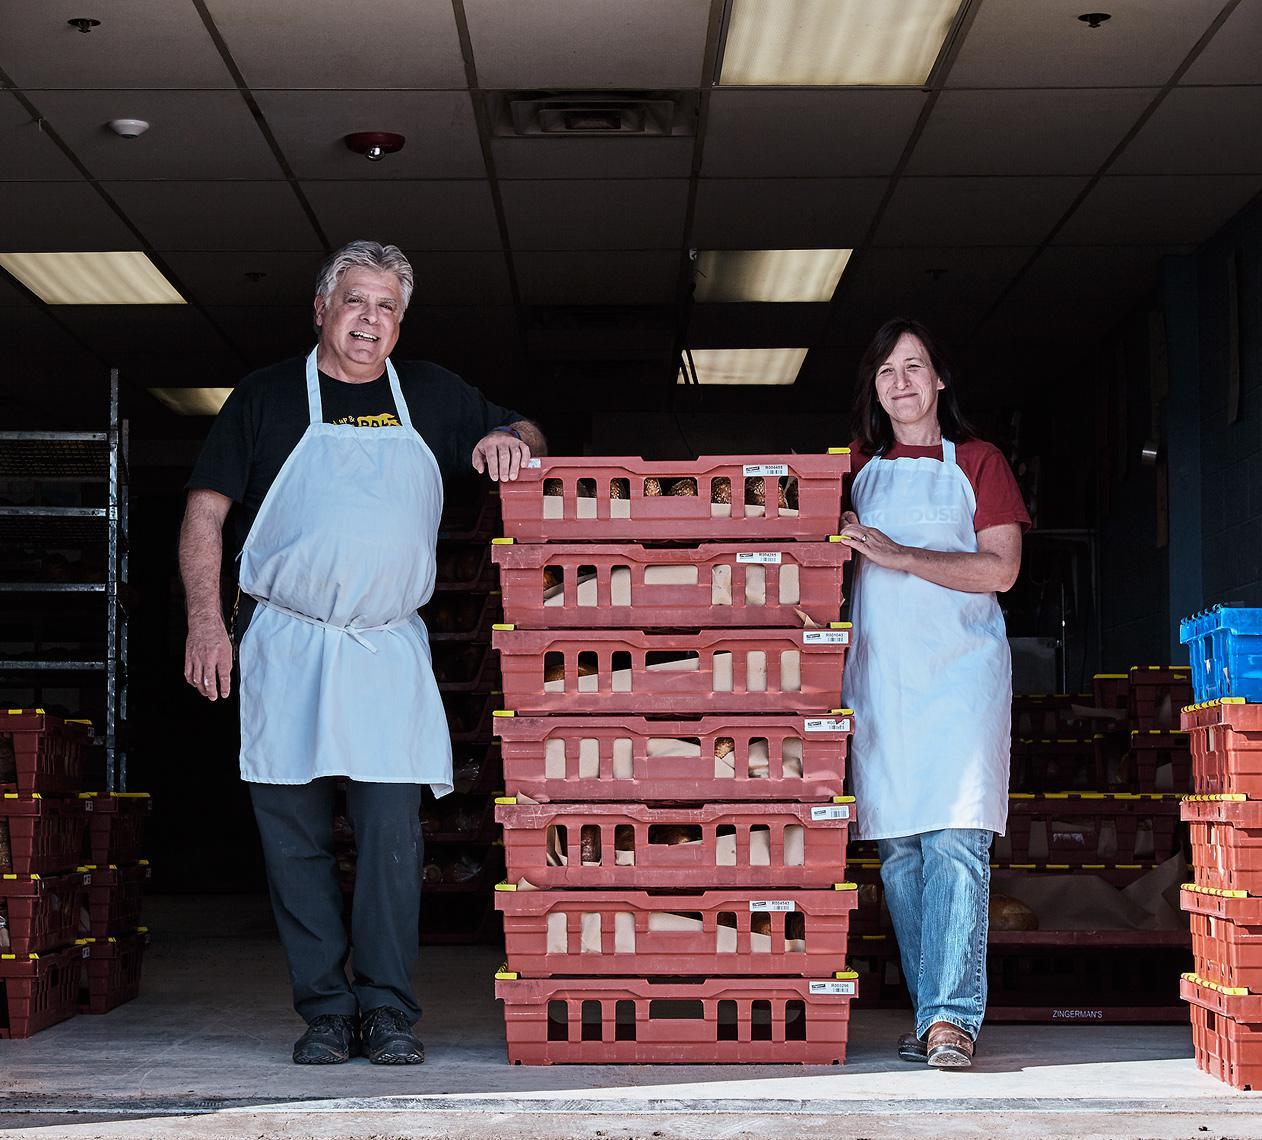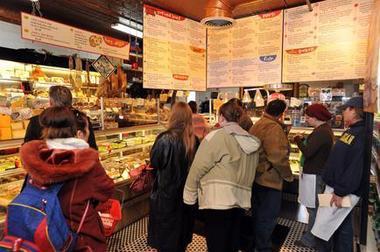The first image is the image on the left, the second image is the image on the right. Given the left and right images, does the statement "There are exactly two people in the left image." hold true? Answer yes or no. Yes. The first image is the image on the left, the second image is the image on the right. Considering the images on both sides, is "The rack of bread in one image is flanked by two people in aprons." valid? Answer yes or no. Yes. 